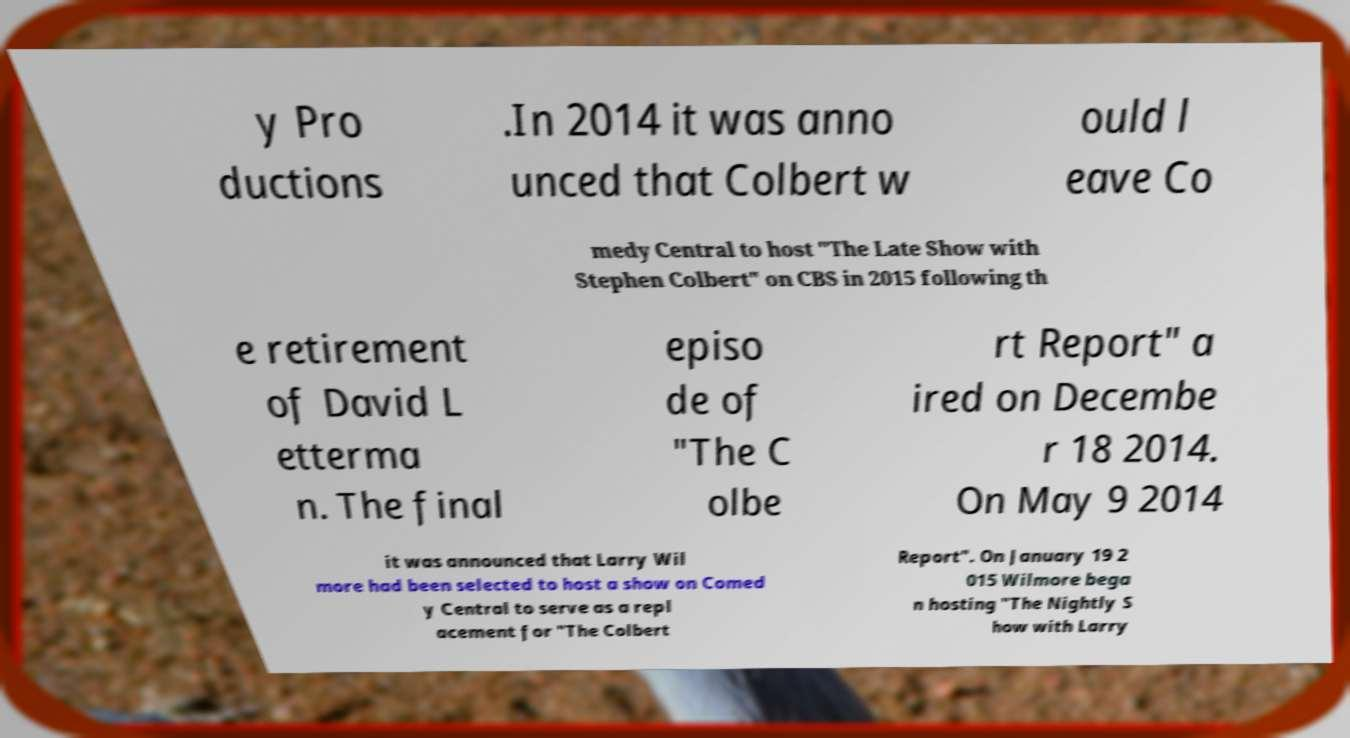There's text embedded in this image that I need extracted. Can you transcribe it verbatim? y Pro ductions .In 2014 it was anno unced that Colbert w ould l eave Co medy Central to host "The Late Show with Stephen Colbert" on CBS in 2015 following th e retirement of David L etterma n. The final episo de of "The C olbe rt Report" a ired on Decembe r 18 2014. On May 9 2014 it was announced that Larry Wil more had been selected to host a show on Comed y Central to serve as a repl acement for "The Colbert Report". On January 19 2 015 Wilmore bega n hosting "The Nightly S how with Larry 